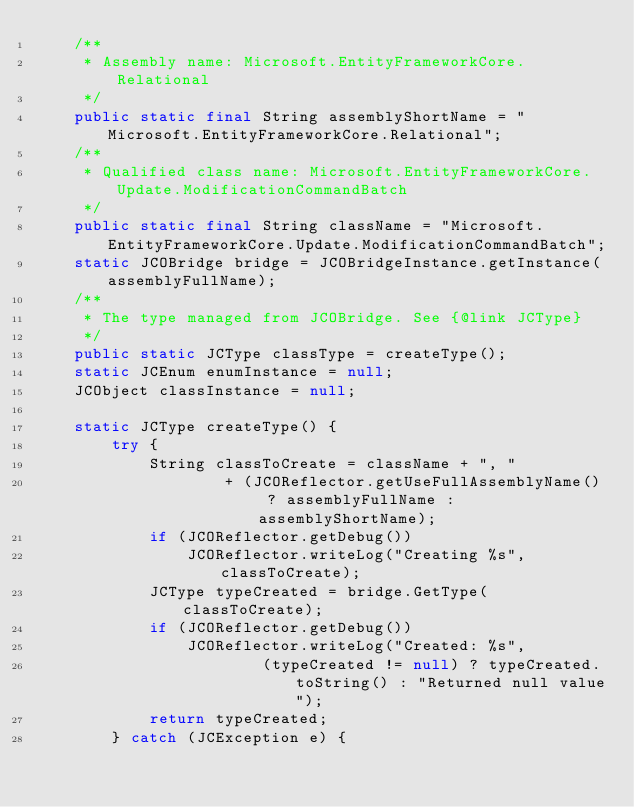Convert code to text. <code><loc_0><loc_0><loc_500><loc_500><_Java_>    /**
     * Assembly name: Microsoft.EntityFrameworkCore.Relational
     */
    public static final String assemblyShortName = "Microsoft.EntityFrameworkCore.Relational";
    /**
     * Qualified class name: Microsoft.EntityFrameworkCore.Update.ModificationCommandBatch
     */
    public static final String className = "Microsoft.EntityFrameworkCore.Update.ModificationCommandBatch";
    static JCOBridge bridge = JCOBridgeInstance.getInstance(assemblyFullName);
    /**
     * The type managed from JCOBridge. See {@link JCType}
     */
    public static JCType classType = createType();
    static JCEnum enumInstance = null;
    JCObject classInstance = null;

    static JCType createType() {
        try {
            String classToCreate = className + ", "
                    + (JCOReflector.getUseFullAssemblyName() ? assemblyFullName : assemblyShortName);
            if (JCOReflector.getDebug())
                JCOReflector.writeLog("Creating %s", classToCreate);
            JCType typeCreated = bridge.GetType(classToCreate);
            if (JCOReflector.getDebug())
                JCOReflector.writeLog("Created: %s",
                        (typeCreated != null) ? typeCreated.toString() : "Returned null value");
            return typeCreated;
        } catch (JCException e) {</code> 